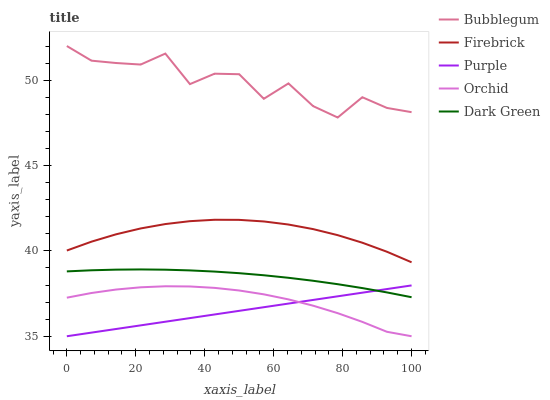Does Purple have the minimum area under the curve?
Answer yes or no. Yes. Does Bubblegum have the maximum area under the curve?
Answer yes or no. Yes. Does Firebrick have the minimum area under the curve?
Answer yes or no. No. Does Firebrick have the maximum area under the curve?
Answer yes or no. No. Is Purple the smoothest?
Answer yes or no. Yes. Is Bubblegum the roughest?
Answer yes or no. Yes. Is Firebrick the smoothest?
Answer yes or no. No. Is Firebrick the roughest?
Answer yes or no. No. Does Firebrick have the lowest value?
Answer yes or no. No. Does Bubblegum have the highest value?
Answer yes or no. Yes. Does Firebrick have the highest value?
Answer yes or no. No. Is Firebrick less than Bubblegum?
Answer yes or no. Yes. Is Bubblegum greater than Orchid?
Answer yes or no. Yes. Does Purple intersect Orchid?
Answer yes or no. Yes. Is Purple less than Orchid?
Answer yes or no. No. Is Purple greater than Orchid?
Answer yes or no. No. Does Firebrick intersect Bubblegum?
Answer yes or no. No. 